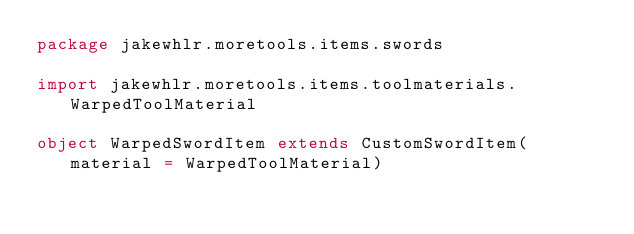<code> <loc_0><loc_0><loc_500><loc_500><_Scala_>package jakewhlr.moretools.items.swords

import jakewhlr.moretools.items.toolmaterials.WarpedToolMaterial

object WarpedSwordItem extends CustomSwordItem(material = WarpedToolMaterial)</code> 